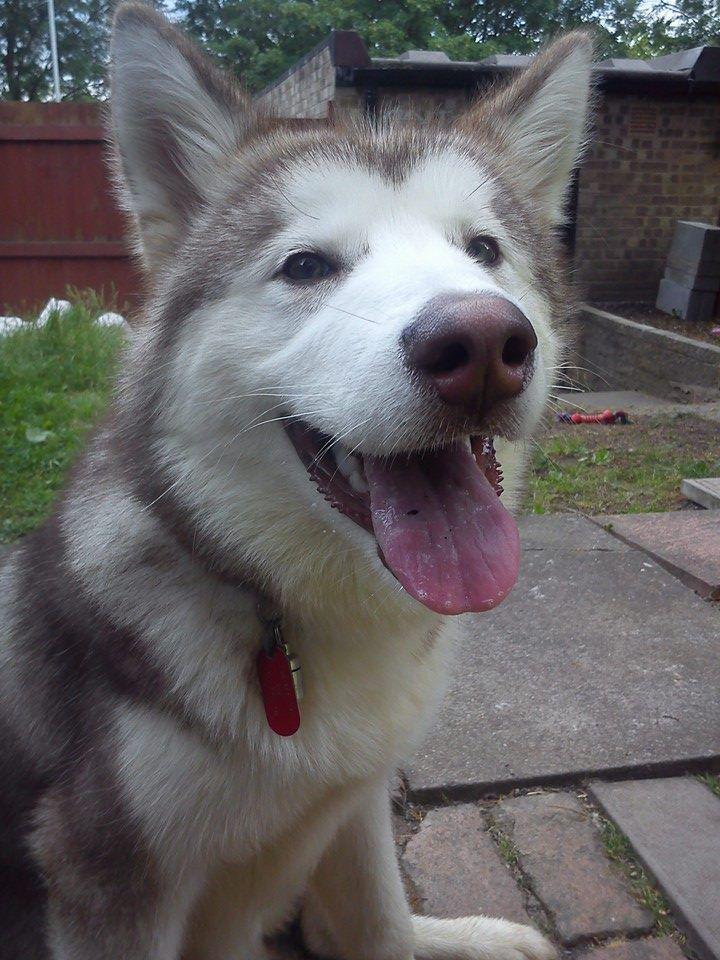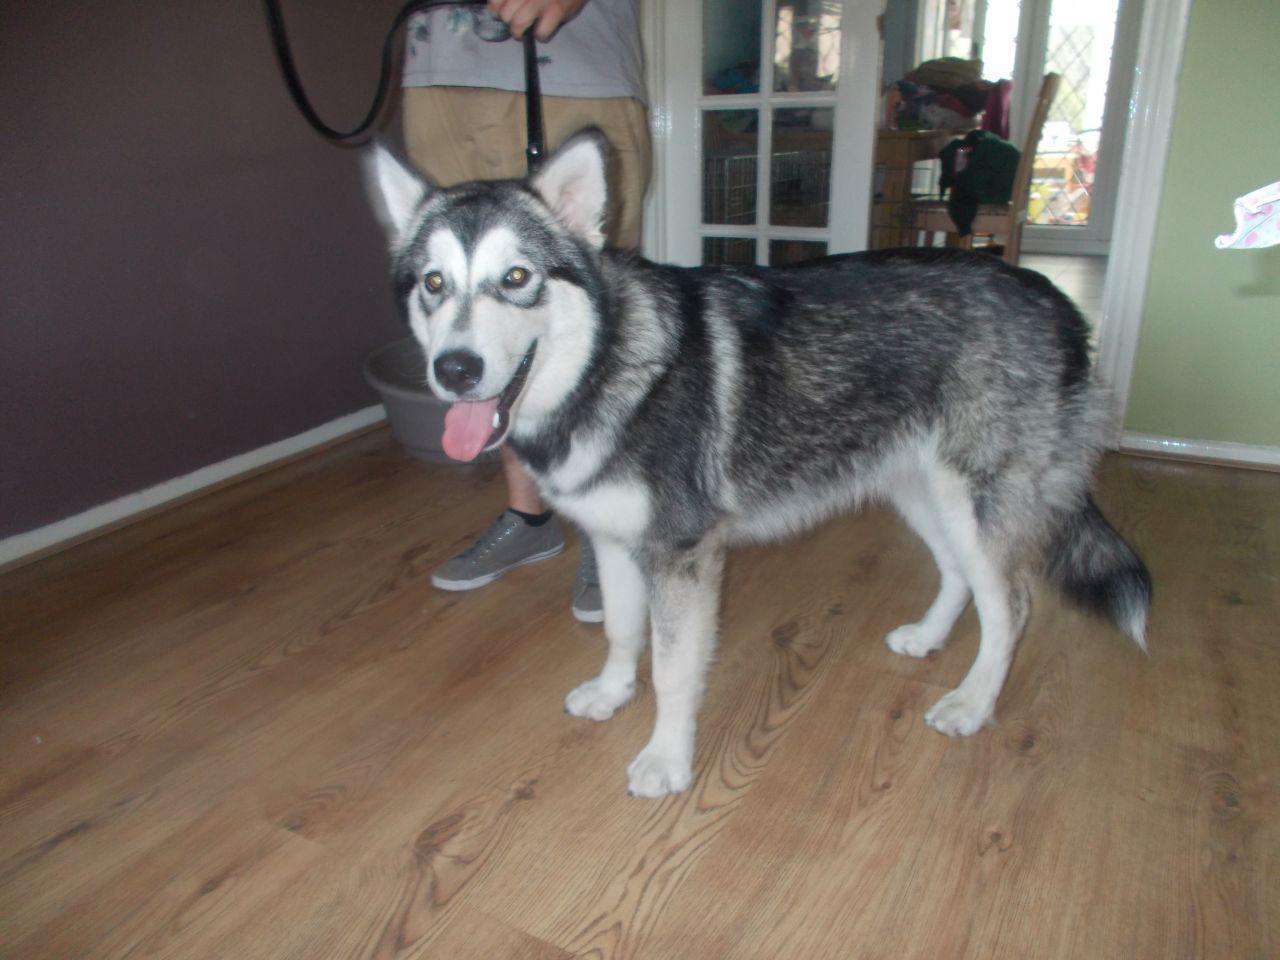The first image is the image on the left, the second image is the image on the right. Examine the images to the left and right. Is the description "The dog in one of the images is standing on the wood planks of a deck outside." accurate? Answer yes or no. No. The first image is the image on the left, the second image is the image on the right. Assess this claim about the two images: "The right image shows a husky standing in profile with its tail curled inward, and the left image shows a dog on a rope in a standing pose in front of an outdoor 'wall'.". Correct or not? Answer yes or no. No. 